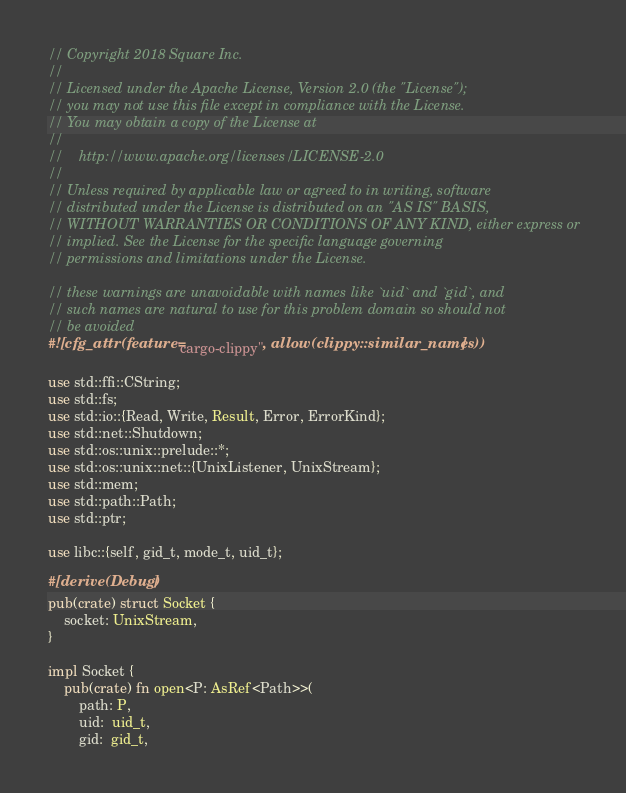Convert code to text. <code><loc_0><loc_0><loc_500><loc_500><_Rust_>// Copyright 2018 Square Inc.
//
// Licensed under the Apache License, Version 2.0 (the "License");
// you may not use this file except in compliance with the License.
// You may obtain a copy of the License at
//
//    http://www.apache.org/licenses/LICENSE-2.0
//
// Unless required by applicable law or agreed to in writing, software
// distributed under the License is distributed on an "AS IS" BASIS,
// WITHOUT WARRANTIES OR CONDITIONS OF ANY KIND, either express or
// implied. See the License for the specific language governing
// permissions and limitations under the License.

// these warnings are unavoidable with names like `uid` and `gid`, and
// such names are natural to use for this problem domain so should not
// be avoided
#![cfg_attr(feature="cargo-clippy", allow(clippy::similar_names))]

use std::ffi::CString;
use std::fs;
use std::io::{Read, Write, Result, Error, ErrorKind};
use std::net::Shutdown;
use std::os::unix::prelude::*;
use std::os::unix::net::{UnixListener, UnixStream};
use std::mem;
use std::path::Path;
use std::ptr;

use libc::{self, gid_t, mode_t, uid_t};

#[derive(Debug)]
pub(crate) struct Socket {
    socket: UnixStream,
}

impl Socket {
    pub(crate) fn open<P: AsRef<Path>>(
        path: P,
        uid:  uid_t,
        gid:  gid_t,</code> 